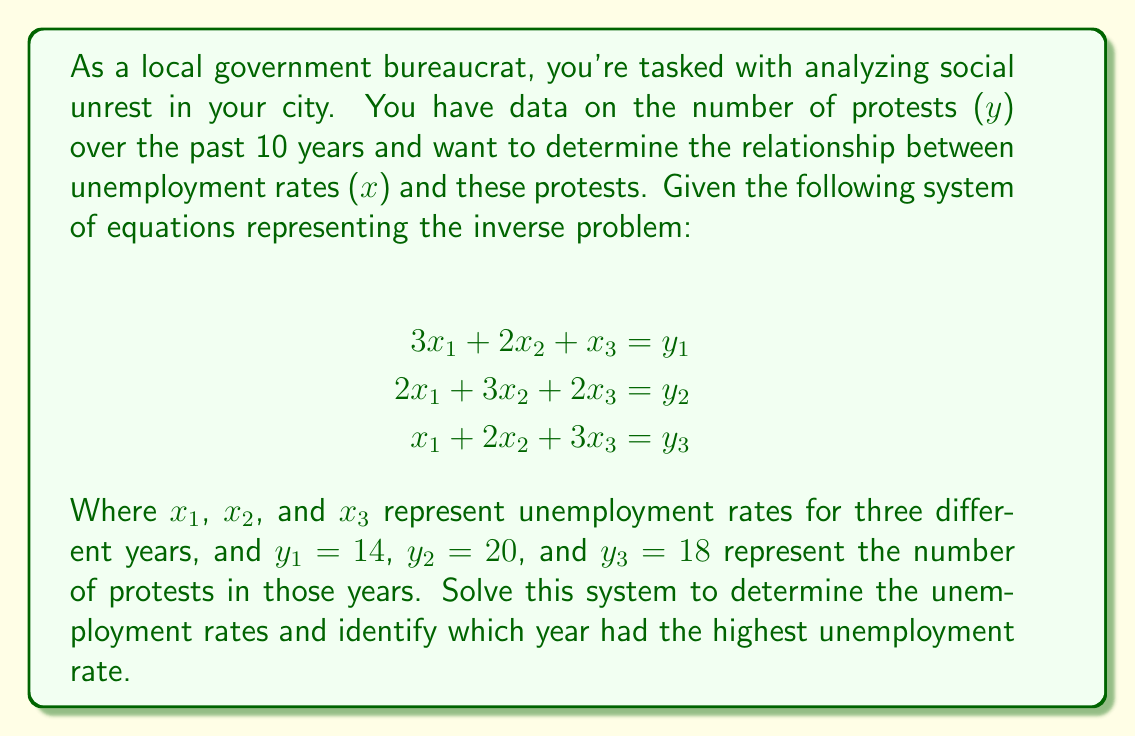What is the answer to this math problem? To solve this inverse problem and determine the unemployment rates, we'll use the Gaussian elimination method:

1. Write the augmented matrix:
   $$\begin{bmatrix}
   3 & 2 & 1 & 14 \\
   2 & 3 & 2 & 20 \\
   1 & 2 & 3 & 18
   \end{bmatrix}$$

2. Perform row operations to get an upper triangular matrix:
   a. $R_2 = R_2 - \frac{2}{3}R_1$
   b. $R_3 = R_3 - \frac{1}{3}R_1$
   
   $$\begin{bmatrix}
   3 & 2 & 1 & 14 \\
   0 & \frac{5}{3} & \frac{4}{3} & \frac{28}{3} \\
   0 & \frac{4}{3} & \frac{8}{3} & 14
   \end{bmatrix}$$

3. Continue row operations:
   c. $R_3 = R_3 - \frac{4}{5}R_2$
   
   $$\begin{bmatrix}
   3 & 2 & 1 & 14 \\
   0 & \frac{5}{3} & \frac{4}{3} & \frac{28}{3} \\
   0 & 0 & \frac{4}{5} & \frac{14}{5}
   \end{bmatrix}$$

4. Back-substitute to find $x_3$, $x_2$, and $x_1$:
   
   $x_3 = \frac{14}{5} \div \frac{4}{5} = \frac{7}{2} = 3.5$
   
   $x_2 = (\frac{28}{3} - \frac{4}{3} \cdot 3.5) \div \frac{5}{3} = 2$
   
   $x_1 = (14 - 2 \cdot 2 - 1 \cdot 3.5) \div 3 = 2.5$

5. Compare the unemployment rates:
   $x_1 = 2.5$, $x_2 = 2$, $x_3 = 3.5$

The highest unemployment rate is $x_3 = 3.5$, corresponding to the third year in the dataset.
Answer: Year 3, with an unemployment rate of 3.5% 